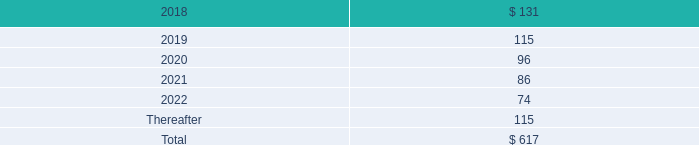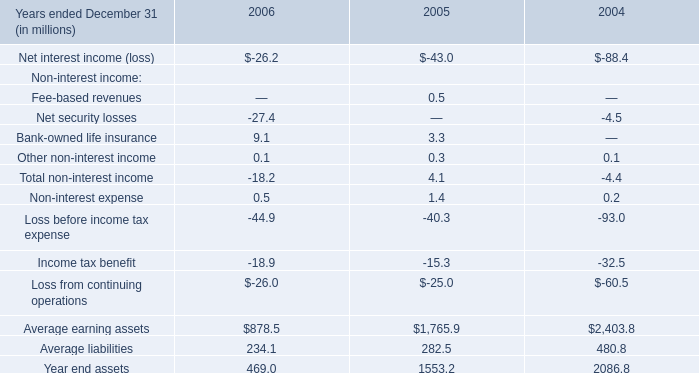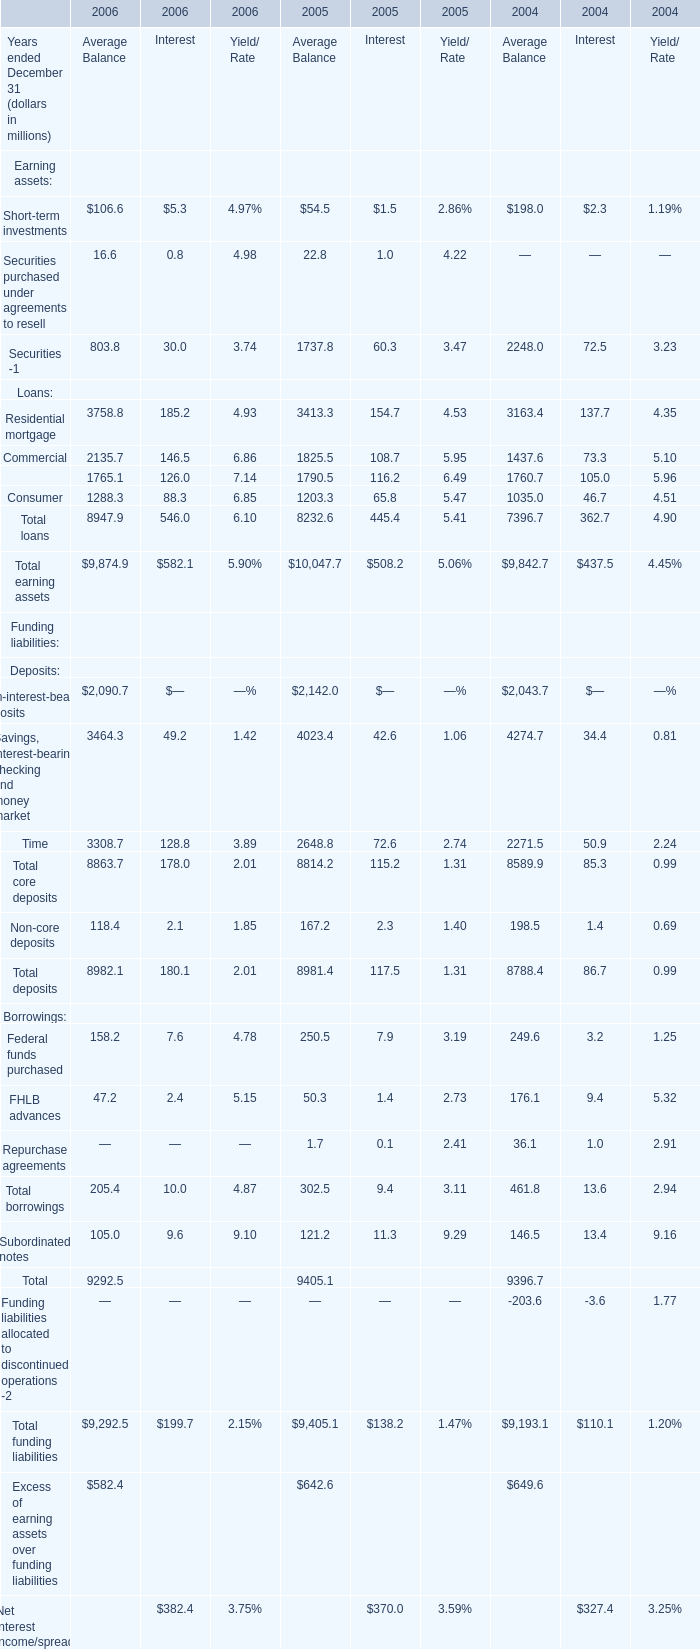what were total r&e expenses in millions for 2017 , 2016 and in 2015? 
Computations: ((201 + 189) + 191)
Answer: 581.0. 